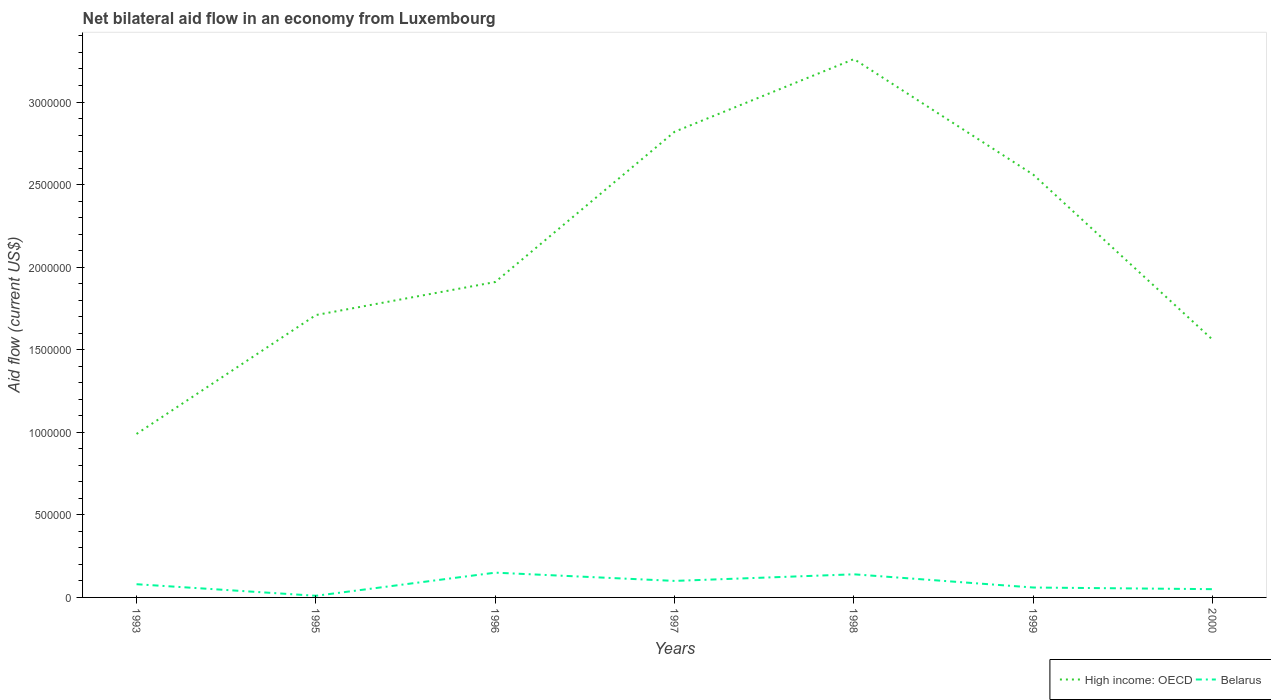How many different coloured lines are there?
Your answer should be very brief. 2. Does the line corresponding to High income: OECD intersect with the line corresponding to Belarus?
Ensure brevity in your answer.  No. What is the total net bilateral aid flow in High income: OECD in the graph?
Your response must be concise. -5.70e+05. What is the difference between the highest and the second highest net bilateral aid flow in High income: OECD?
Your response must be concise. 2.27e+06. What is the difference between the highest and the lowest net bilateral aid flow in High income: OECD?
Provide a short and direct response. 3. Is the net bilateral aid flow in High income: OECD strictly greater than the net bilateral aid flow in Belarus over the years?
Your answer should be very brief. No. How many years are there in the graph?
Make the answer very short. 7. What is the difference between two consecutive major ticks on the Y-axis?
Provide a succinct answer. 5.00e+05. Are the values on the major ticks of Y-axis written in scientific E-notation?
Give a very brief answer. No. Does the graph contain any zero values?
Your response must be concise. No. Does the graph contain grids?
Offer a very short reply. No. How many legend labels are there?
Offer a very short reply. 2. What is the title of the graph?
Ensure brevity in your answer.  Net bilateral aid flow in an economy from Luxembourg. Does "Singapore" appear as one of the legend labels in the graph?
Offer a very short reply. No. What is the label or title of the X-axis?
Your answer should be compact. Years. What is the label or title of the Y-axis?
Your answer should be compact. Aid flow (current US$). What is the Aid flow (current US$) of High income: OECD in 1993?
Provide a succinct answer. 9.90e+05. What is the Aid flow (current US$) of Belarus in 1993?
Keep it short and to the point. 8.00e+04. What is the Aid flow (current US$) of High income: OECD in 1995?
Your answer should be compact. 1.71e+06. What is the Aid flow (current US$) in High income: OECD in 1996?
Make the answer very short. 1.91e+06. What is the Aid flow (current US$) in High income: OECD in 1997?
Offer a terse response. 2.82e+06. What is the Aid flow (current US$) in High income: OECD in 1998?
Your answer should be very brief. 3.26e+06. What is the Aid flow (current US$) in High income: OECD in 1999?
Keep it short and to the point. 2.56e+06. What is the Aid flow (current US$) in Belarus in 1999?
Provide a succinct answer. 6.00e+04. What is the Aid flow (current US$) of High income: OECD in 2000?
Provide a short and direct response. 1.56e+06. What is the Aid flow (current US$) in Belarus in 2000?
Give a very brief answer. 5.00e+04. Across all years, what is the maximum Aid flow (current US$) of High income: OECD?
Your answer should be compact. 3.26e+06. Across all years, what is the maximum Aid flow (current US$) of Belarus?
Provide a succinct answer. 1.50e+05. Across all years, what is the minimum Aid flow (current US$) in High income: OECD?
Ensure brevity in your answer.  9.90e+05. Across all years, what is the minimum Aid flow (current US$) of Belarus?
Your answer should be very brief. 10000. What is the total Aid flow (current US$) in High income: OECD in the graph?
Offer a terse response. 1.48e+07. What is the total Aid flow (current US$) in Belarus in the graph?
Keep it short and to the point. 5.90e+05. What is the difference between the Aid flow (current US$) in High income: OECD in 1993 and that in 1995?
Provide a short and direct response. -7.20e+05. What is the difference between the Aid flow (current US$) of Belarus in 1993 and that in 1995?
Provide a succinct answer. 7.00e+04. What is the difference between the Aid flow (current US$) in High income: OECD in 1993 and that in 1996?
Your response must be concise. -9.20e+05. What is the difference between the Aid flow (current US$) in High income: OECD in 1993 and that in 1997?
Make the answer very short. -1.83e+06. What is the difference between the Aid flow (current US$) of High income: OECD in 1993 and that in 1998?
Give a very brief answer. -2.27e+06. What is the difference between the Aid flow (current US$) in Belarus in 1993 and that in 1998?
Your response must be concise. -6.00e+04. What is the difference between the Aid flow (current US$) in High income: OECD in 1993 and that in 1999?
Keep it short and to the point. -1.57e+06. What is the difference between the Aid flow (current US$) in High income: OECD in 1993 and that in 2000?
Provide a short and direct response. -5.70e+05. What is the difference between the Aid flow (current US$) of Belarus in 1993 and that in 2000?
Make the answer very short. 3.00e+04. What is the difference between the Aid flow (current US$) of High income: OECD in 1995 and that in 1997?
Provide a succinct answer. -1.11e+06. What is the difference between the Aid flow (current US$) in Belarus in 1995 and that in 1997?
Keep it short and to the point. -9.00e+04. What is the difference between the Aid flow (current US$) in High income: OECD in 1995 and that in 1998?
Offer a very short reply. -1.55e+06. What is the difference between the Aid flow (current US$) in High income: OECD in 1995 and that in 1999?
Your response must be concise. -8.50e+05. What is the difference between the Aid flow (current US$) in High income: OECD in 1995 and that in 2000?
Give a very brief answer. 1.50e+05. What is the difference between the Aid flow (current US$) in Belarus in 1995 and that in 2000?
Your answer should be compact. -4.00e+04. What is the difference between the Aid flow (current US$) of High income: OECD in 1996 and that in 1997?
Your answer should be compact. -9.10e+05. What is the difference between the Aid flow (current US$) in High income: OECD in 1996 and that in 1998?
Keep it short and to the point. -1.35e+06. What is the difference between the Aid flow (current US$) in High income: OECD in 1996 and that in 1999?
Offer a very short reply. -6.50e+05. What is the difference between the Aid flow (current US$) of High income: OECD in 1996 and that in 2000?
Your answer should be very brief. 3.50e+05. What is the difference between the Aid flow (current US$) in Belarus in 1996 and that in 2000?
Your answer should be compact. 1.00e+05. What is the difference between the Aid flow (current US$) of High income: OECD in 1997 and that in 1998?
Provide a succinct answer. -4.40e+05. What is the difference between the Aid flow (current US$) of Belarus in 1997 and that in 1998?
Your response must be concise. -4.00e+04. What is the difference between the Aid flow (current US$) of High income: OECD in 1997 and that in 2000?
Offer a terse response. 1.26e+06. What is the difference between the Aid flow (current US$) in Belarus in 1997 and that in 2000?
Give a very brief answer. 5.00e+04. What is the difference between the Aid flow (current US$) in High income: OECD in 1998 and that in 1999?
Keep it short and to the point. 7.00e+05. What is the difference between the Aid flow (current US$) of Belarus in 1998 and that in 1999?
Your answer should be compact. 8.00e+04. What is the difference between the Aid flow (current US$) in High income: OECD in 1998 and that in 2000?
Your answer should be compact. 1.70e+06. What is the difference between the Aid flow (current US$) in Belarus in 1998 and that in 2000?
Keep it short and to the point. 9.00e+04. What is the difference between the Aid flow (current US$) in High income: OECD in 1999 and that in 2000?
Offer a terse response. 1.00e+06. What is the difference between the Aid flow (current US$) in Belarus in 1999 and that in 2000?
Provide a succinct answer. 10000. What is the difference between the Aid flow (current US$) of High income: OECD in 1993 and the Aid flow (current US$) of Belarus in 1995?
Offer a very short reply. 9.80e+05. What is the difference between the Aid flow (current US$) in High income: OECD in 1993 and the Aid flow (current US$) in Belarus in 1996?
Keep it short and to the point. 8.40e+05. What is the difference between the Aid flow (current US$) in High income: OECD in 1993 and the Aid flow (current US$) in Belarus in 1997?
Keep it short and to the point. 8.90e+05. What is the difference between the Aid flow (current US$) in High income: OECD in 1993 and the Aid flow (current US$) in Belarus in 1998?
Offer a very short reply. 8.50e+05. What is the difference between the Aid flow (current US$) of High income: OECD in 1993 and the Aid flow (current US$) of Belarus in 1999?
Ensure brevity in your answer.  9.30e+05. What is the difference between the Aid flow (current US$) in High income: OECD in 1993 and the Aid flow (current US$) in Belarus in 2000?
Offer a very short reply. 9.40e+05. What is the difference between the Aid flow (current US$) of High income: OECD in 1995 and the Aid flow (current US$) of Belarus in 1996?
Provide a succinct answer. 1.56e+06. What is the difference between the Aid flow (current US$) of High income: OECD in 1995 and the Aid flow (current US$) of Belarus in 1997?
Offer a very short reply. 1.61e+06. What is the difference between the Aid flow (current US$) of High income: OECD in 1995 and the Aid flow (current US$) of Belarus in 1998?
Give a very brief answer. 1.57e+06. What is the difference between the Aid flow (current US$) in High income: OECD in 1995 and the Aid flow (current US$) in Belarus in 1999?
Your response must be concise. 1.65e+06. What is the difference between the Aid flow (current US$) of High income: OECD in 1995 and the Aid flow (current US$) of Belarus in 2000?
Give a very brief answer. 1.66e+06. What is the difference between the Aid flow (current US$) of High income: OECD in 1996 and the Aid flow (current US$) of Belarus in 1997?
Give a very brief answer. 1.81e+06. What is the difference between the Aid flow (current US$) in High income: OECD in 1996 and the Aid flow (current US$) in Belarus in 1998?
Provide a short and direct response. 1.77e+06. What is the difference between the Aid flow (current US$) in High income: OECD in 1996 and the Aid flow (current US$) in Belarus in 1999?
Your answer should be very brief. 1.85e+06. What is the difference between the Aid flow (current US$) in High income: OECD in 1996 and the Aid flow (current US$) in Belarus in 2000?
Your answer should be compact. 1.86e+06. What is the difference between the Aid flow (current US$) of High income: OECD in 1997 and the Aid flow (current US$) of Belarus in 1998?
Your answer should be compact. 2.68e+06. What is the difference between the Aid flow (current US$) in High income: OECD in 1997 and the Aid flow (current US$) in Belarus in 1999?
Offer a terse response. 2.76e+06. What is the difference between the Aid flow (current US$) of High income: OECD in 1997 and the Aid flow (current US$) of Belarus in 2000?
Your response must be concise. 2.77e+06. What is the difference between the Aid flow (current US$) of High income: OECD in 1998 and the Aid flow (current US$) of Belarus in 1999?
Offer a very short reply. 3.20e+06. What is the difference between the Aid flow (current US$) of High income: OECD in 1998 and the Aid flow (current US$) of Belarus in 2000?
Offer a terse response. 3.21e+06. What is the difference between the Aid flow (current US$) of High income: OECD in 1999 and the Aid flow (current US$) of Belarus in 2000?
Provide a succinct answer. 2.51e+06. What is the average Aid flow (current US$) in High income: OECD per year?
Give a very brief answer. 2.12e+06. What is the average Aid flow (current US$) in Belarus per year?
Keep it short and to the point. 8.43e+04. In the year 1993, what is the difference between the Aid flow (current US$) in High income: OECD and Aid flow (current US$) in Belarus?
Make the answer very short. 9.10e+05. In the year 1995, what is the difference between the Aid flow (current US$) of High income: OECD and Aid flow (current US$) of Belarus?
Your answer should be very brief. 1.70e+06. In the year 1996, what is the difference between the Aid flow (current US$) in High income: OECD and Aid flow (current US$) in Belarus?
Offer a very short reply. 1.76e+06. In the year 1997, what is the difference between the Aid flow (current US$) of High income: OECD and Aid flow (current US$) of Belarus?
Your answer should be very brief. 2.72e+06. In the year 1998, what is the difference between the Aid flow (current US$) of High income: OECD and Aid flow (current US$) of Belarus?
Provide a short and direct response. 3.12e+06. In the year 1999, what is the difference between the Aid flow (current US$) of High income: OECD and Aid flow (current US$) of Belarus?
Make the answer very short. 2.50e+06. In the year 2000, what is the difference between the Aid flow (current US$) of High income: OECD and Aid flow (current US$) of Belarus?
Offer a terse response. 1.51e+06. What is the ratio of the Aid flow (current US$) in High income: OECD in 1993 to that in 1995?
Provide a short and direct response. 0.58. What is the ratio of the Aid flow (current US$) in Belarus in 1993 to that in 1995?
Give a very brief answer. 8. What is the ratio of the Aid flow (current US$) of High income: OECD in 1993 to that in 1996?
Give a very brief answer. 0.52. What is the ratio of the Aid flow (current US$) in Belarus in 1993 to that in 1996?
Provide a succinct answer. 0.53. What is the ratio of the Aid flow (current US$) in High income: OECD in 1993 to that in 1997?
Offer a very short reply. 0.35. What is the ratio of the Aid flow (current US$) in High income: OECD in 1993 to that in 1998?
Ensure brevity in your answer.  0.3. What is the ratio of the Aid flow (current US$) in Belarus in 1993 to that in 1998?
Give a very brief answer. 0.57. What is the ratio of the Aid flow (current US$) in High income: OECD in 1993 to that in 1999?
Ensure brevity in your answer.  0.39. What is the ratio of the Aid flow (current US$) of High income: OECD in 1993 to that in 2000?
Your answer should be very brief. 0.63. What is the ratio of the Aid flow (current US$) of Belarus in 1993 to that in 2000?
Provide a succinct answer. 1.6. What is the ratio of the Aid flow (current US$) of High income: OECD in 1995 to that in 1996?
Give a very brief answer. 0.9. What is the ratio of the Aid flow (current US$) in Belarus in 1995 to that in 1996?
Provide a succinct answer. 0.07. What is the ratio of the Aid flow (current US$) of High income: OECD in 1995 to that in 1997?
Offer a very short reply. 0.61. What is the ratio of the Aid flow (current US$) in Belarus in 1995 to that in 1997?
Offer a very short reply. 0.1. What is the ratio of the Aid flow (current US$) in High income: OECD in 1995 to that in 1998?
Provide a succinct answer. 0.52. What is the ratio of the Aid flow (current US$) in Belarus in 1995 to that in 1998?
Your answer should be compact. 0.07. What is the ratio of the Aid flow (current US$) of High income: OECD in 1995 to that in 1999?
Ensure brevity in your answer.  0.67. What is the ratio of the Aid flow (current US$) of High income: OECD in 1995 to that in 2000?
Provide a short and direct response. 1.1. What is the ratio of the Aid flow (current US$) in High income: OECD in 1996 to that in 1997?
Make the answer very short. 0.68. What is the ratio of the Aid flow (current US$) in High income: OECD in 1996 to that in 1998?
Provide a succinct answer. 0.59. What is the ratio of the Aid flow (current US$) in Belarus in 1996 to that in 1998?
Give a very brief answer. 1.07. What is the ratio of the Aid flow (current US$) of High income: OECD in 1996 to that in 1999?
Make the answer very short. 0.75. What is the ratio of the Aid flow (current US$) of Belarus in 1996 to that in 1999?
Make the answer very short. 2.5. What is the ratio of the Aid flow (current US$) in High income: OECD in 1996 to that in 2000?
Your answer should be very brief. 1.22. What is the ratio of the Aid flow (current US$) of High income: OECD in 1997 to that in 1998?
Your answer should be compact. 0.86. What is the ratio of the Aid flow (current US$) of High income: OECD in 1997 to that in 1999?
Give a very brief answer. 1.1. What is the ratio of the Aid flow (current US$) of Belarus in 1997 to that in 1999?
Provide a succinct answer. 1.67. What is the ratio of the Aid flow (current US$) of High income: OECD in 1997 to that in 2000?
Offer a terse response. 1.81. What is the ratio of the Aid flow (current US$) in Belarus in 1997 to that in 2000?
Provide a succinct answer. 2. What is the ratio of the Aid flow (current US$) of High income: OECD in 1998 to that in 1999?
Provide a short and direct response. 1.27. What is the ratio of the Aid flow (current US$) in Belarus in 1998 to that in 1999?
Make the answer very short. 2.33. What is the ratio of the Aid flow (current US$) in High income: OECD in 1998 to that in 2000?
Your answer should be compact. 2.09. What is the ratio of the Aid flow (current US$) in Belarus in 1998 to that in 2000?
Ensure brevity in your answer.  2.8. What is the ratio of the Aid flow (current US$) in High income: OECD in 1999 to that in 2000?
Ensure brevity in your answer.  1.64. What is the ratio of the Aid flow (current US$) in Belarus in 1999 to that in 2000?
Keep it short and to the point. 1.2. What is the difference between the highest and the lowest Aid flow (current US$) of High income: OECD?
Provide a short and direct response. 2.27e+06. 